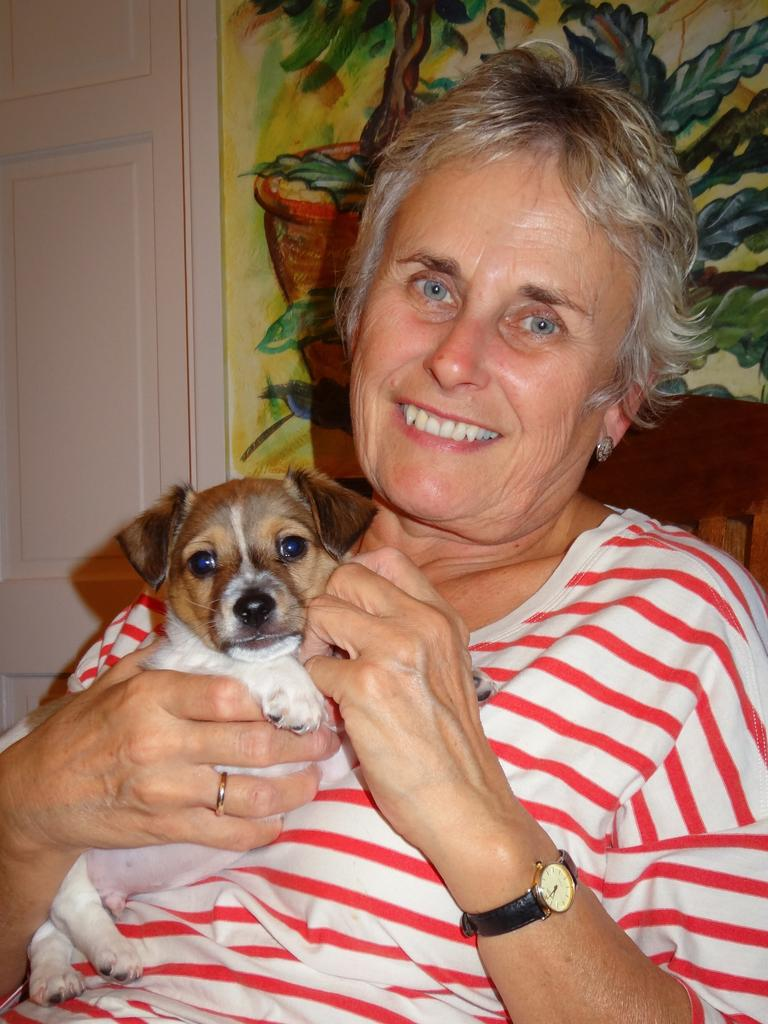Who is present in the image? There is a woman in the image. What is the woman holding? The woman is holding a dog. What expression does the woman have? The woman is smiling. What can be seen in the background of the image? There is a painting in the background of the image. What type of square waste can be seen in the image? There is no square waste present in the image. 